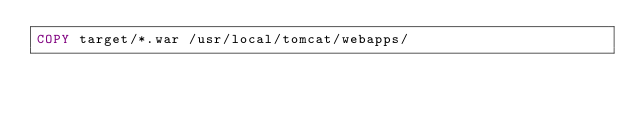Convert code to text. <code><loc_0><loc_0><loc_500><loc_500><_Dockerfile_>COPY target/*.war /usr/local/tomcat/webapps/
</code> 